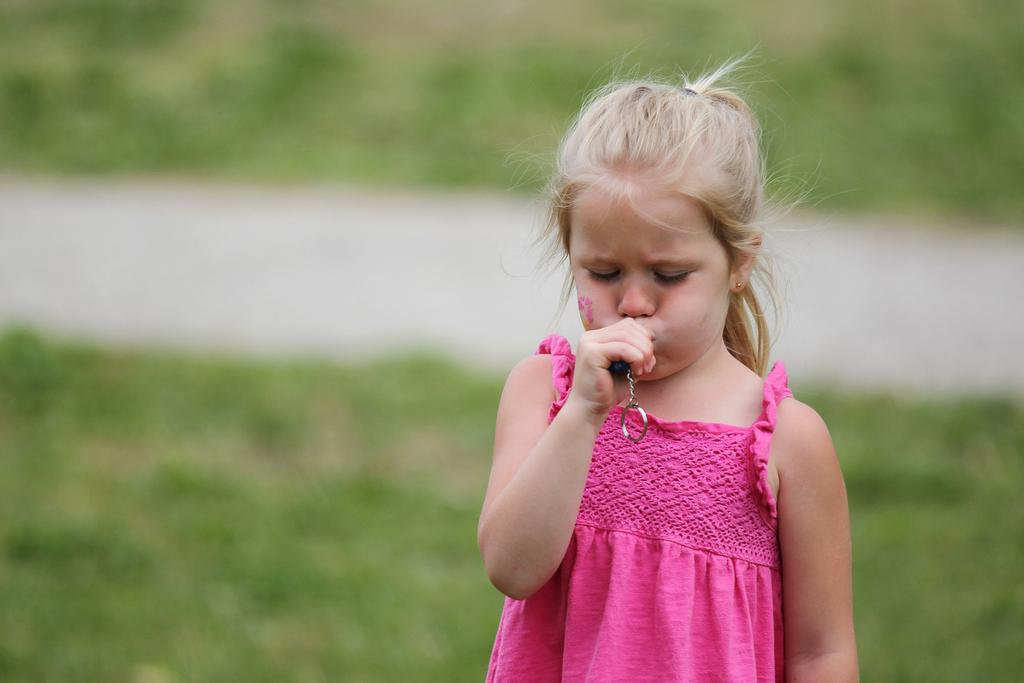What is the main subject in the foreground of the image? There is a girl in the foreground of the image. What is the girl wearing? The girl is wearing a pink dress. What object is the girl holding in her hand? The girl is holding a key chain-like object. How would you describe the background of the image? The background of the image is blurred. Can you see a tiger in the background of the image? No, there is no tiger present in the image. What type of root is growing near the girl in the image? There are no roots visible in the image; it features a girl in the foreground and a blurred background. 